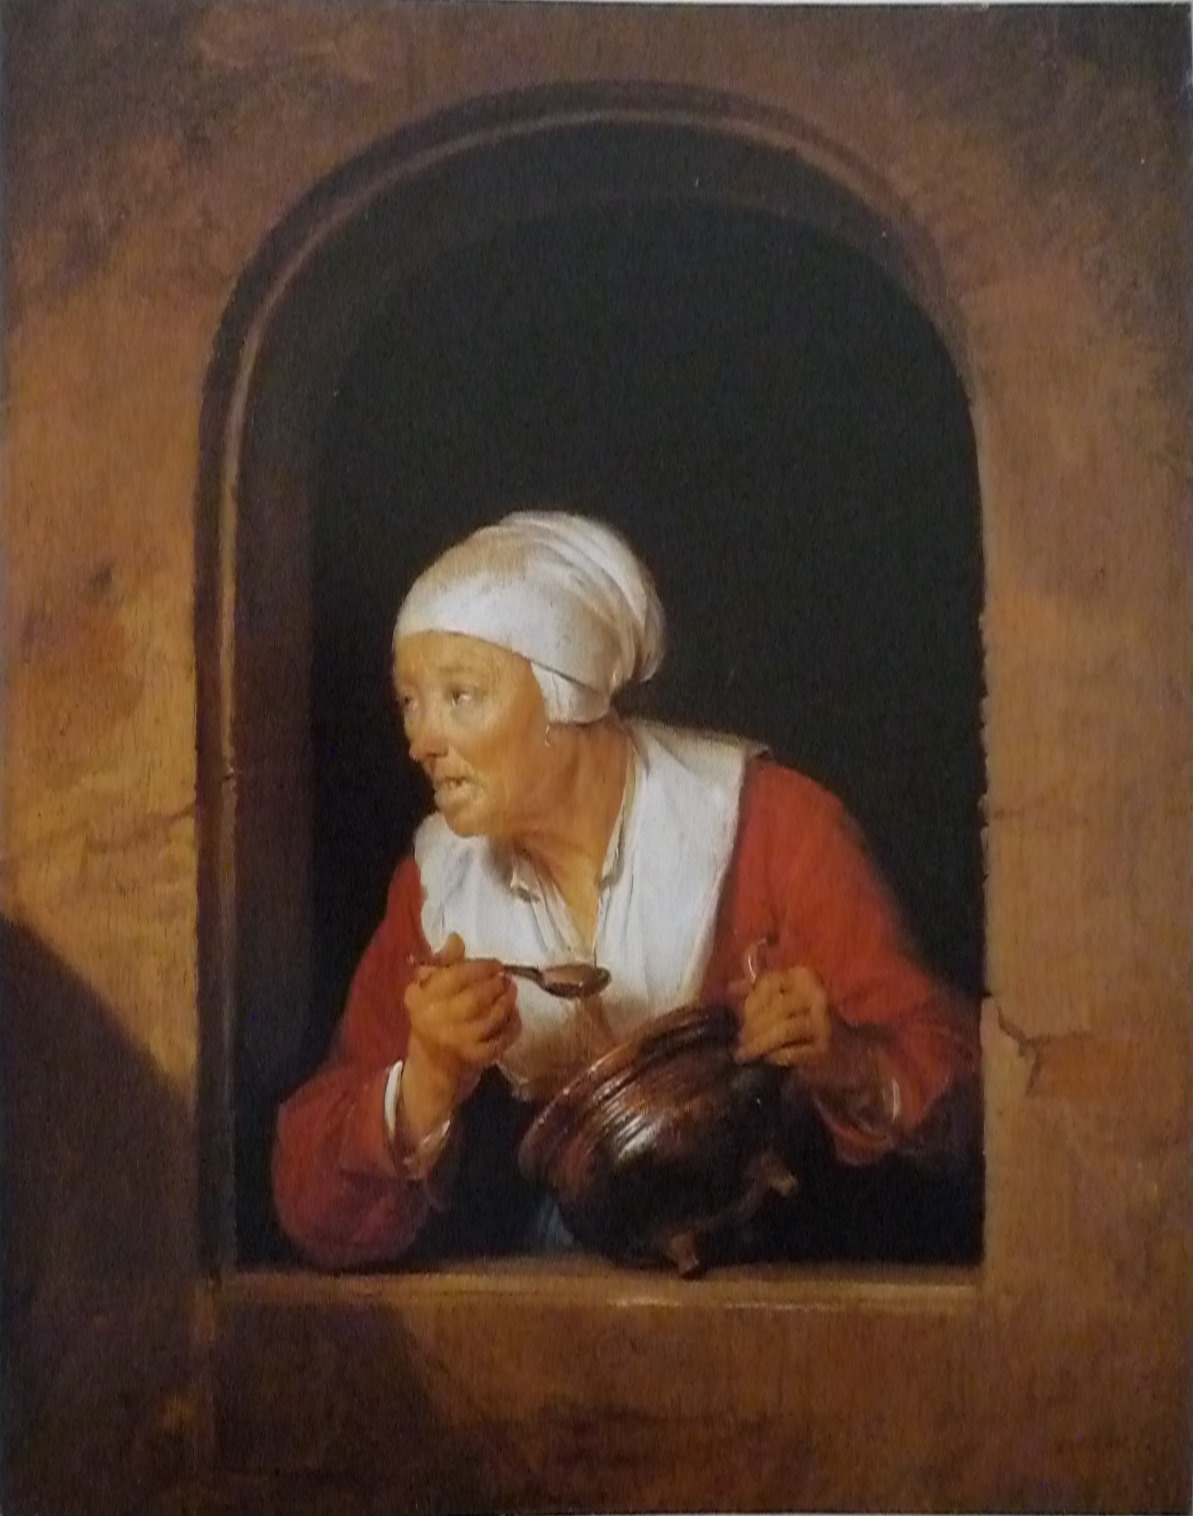Write a detailed description of the given image. The image portrays an elderly woman depicted in the rich Baroque artistic style of the 17th century. She is shown leaning slightly out of a window, dressed in a striking red blouse and white headscarf, indicative of her age or social status. Her facial expression denotes surprise or curiosity, adding an engaging narrative quality to the scene. The woman holds a brown jug in one hand and a spoon in the other, suggesting she might be in the middle of cooking or serving food. The window's stone frame serves as a rustic backdrop, enhancing the artwork's historical and realistic feel. The artist’s adept use of light and shadow creates depth, making the figure appear almost three-dimensional and lifelike, a characteristic hallmark of the Baroque period. Overall, this painting offers a vivid glimpse into the daily life and attire of the era, masterfully captured through meticulous detail and dramatic expression. 